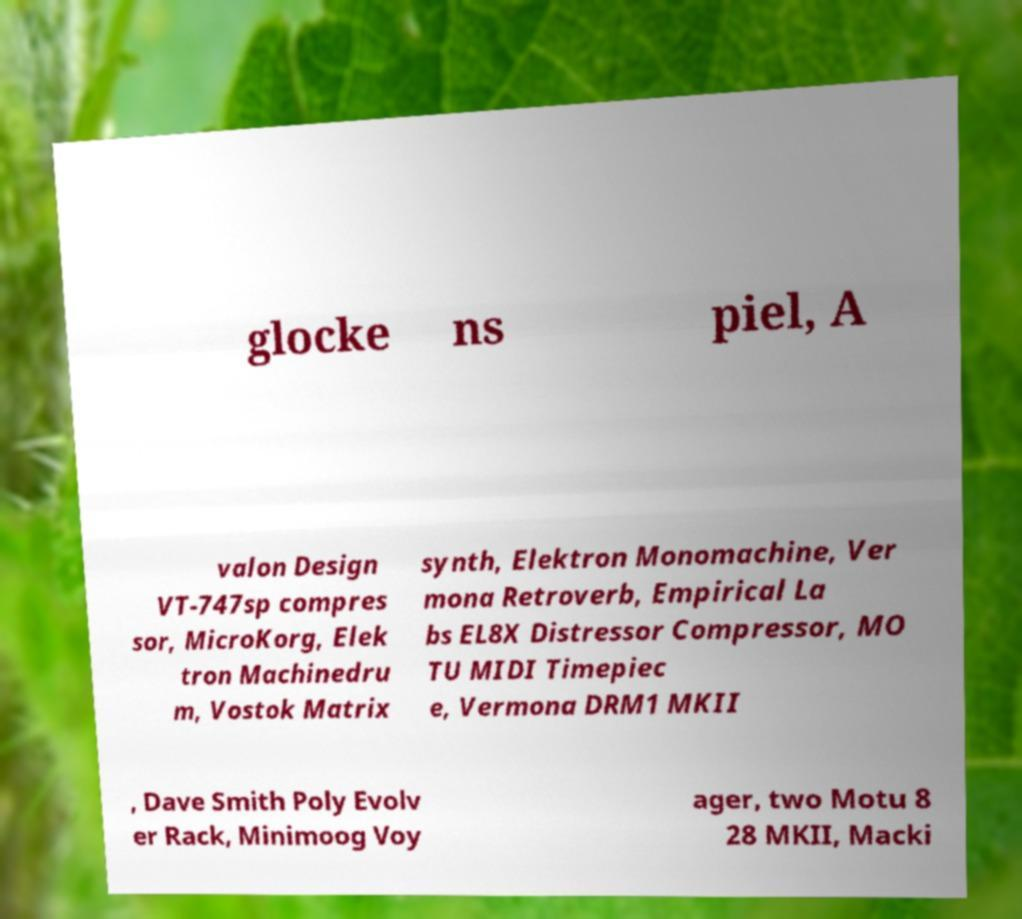Please identify and transcribe the text found in this image. glocke ns piel, A valon Design VT-747sp compres sor, MicroKorg, Elek tron Machinedru m, Vostok Matrix synth, Elektron Monomachine, Ver mona Retroverb, Empirical La bs EL8X Distressor Compressor, MO TU MIDI Timepiec e, Vermona DRM1 MKII , Dave Smith Poly Evolv er Rack, Minimoog Voy ager, two Motu 8 28 MKII, Macki 